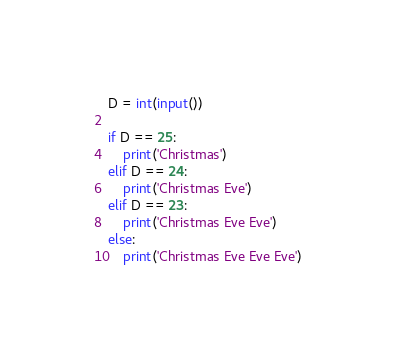Convert code to text. <code><loc_0><loc_0><loc_500><loc_500><_Python_>D = int(input())

if D == 25:
    print('Christmas')
elif D == 24:
    print('Christmas Eve')
elif D == 23:
    print('Christmas Eve Eve')
else:
    print('Christmas Eve Eve Eve')</code> 